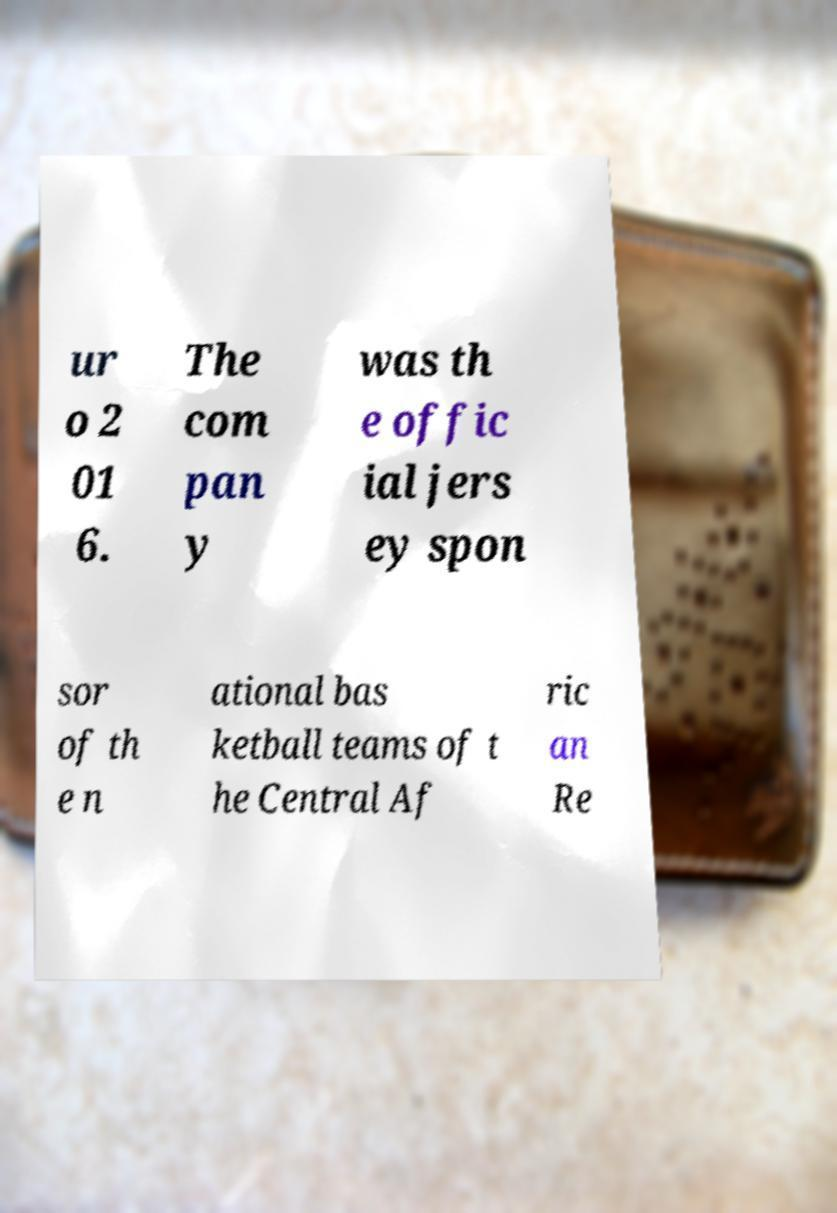Can you read and provide the text displayed in the image?This photo seems to have some interesting text. Can you extract and type it out for me? ur o 2 01 6. The com pan y was th e offic ial jers ey spon sor of th e n ational bas ketball teams of t he Central Af ric an Re 